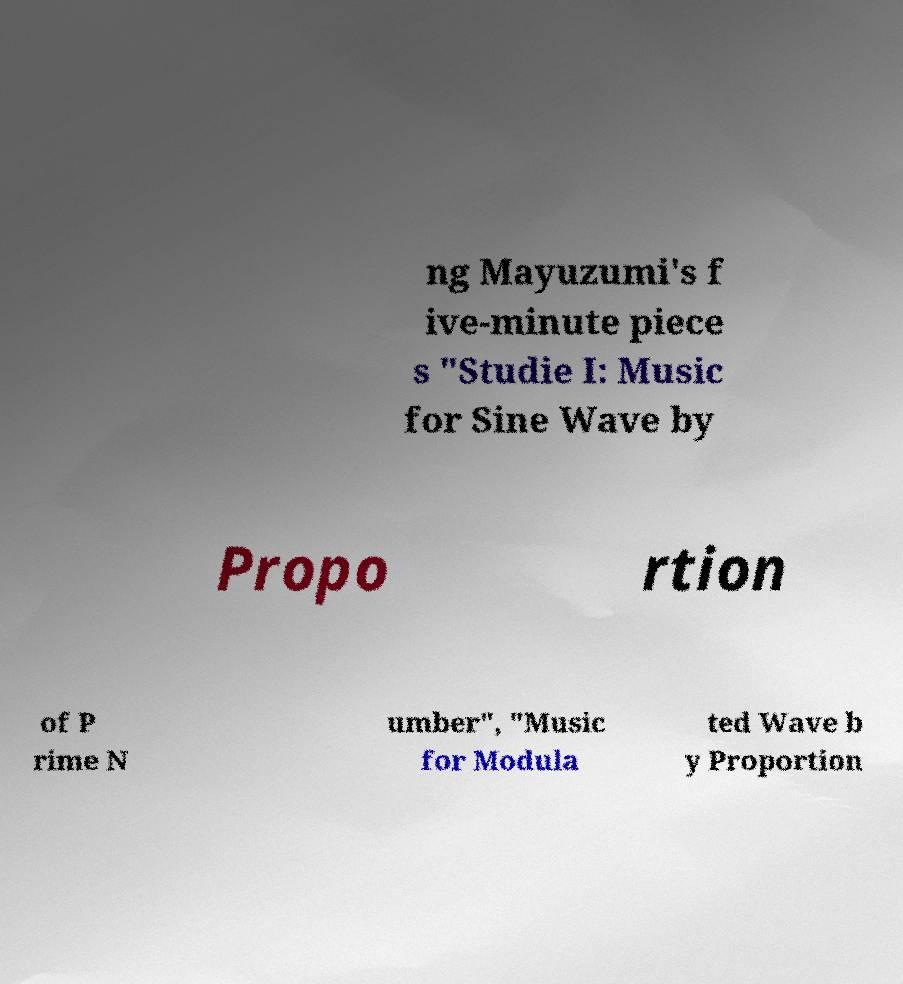Could you assist in decoding the text presented in this image and type it out clearly? ng Mayuzumi's f ive-minute piece s "Studie I: Music for Sine Wave by Propo rtion of P rime N umber", "Music for Modula ted Wave b y Proportion 